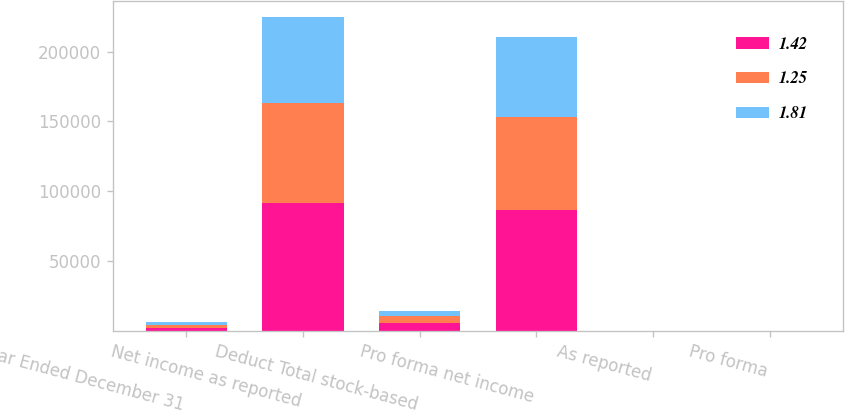<chart> <loc_0><loc_0><loc_500><loc_500><stacked_bar_chart><ecel><fcel>Year Ended December 31<fcel>Net income as reported<fcel>Deduct Total stock-based<fcel>Pro forma net income<fcel>As reported<fcel>Pro forma<nl><fcel>1.42<fcel>2003<fcel>91696<fcel>5374<fcel>86322<fcel>1.95<fcel>1.83<nl><fcel>1.25<fcel>2002<fcel>71595<fcel>5102<fcel>66493<fcel>1.54<fcel>1.43<nl><fcel>1.81<fcel>2001<fcel>61529<fcel>3558<fcel>57971<fcel>1.34<fcel>1.26<nl></chart> 